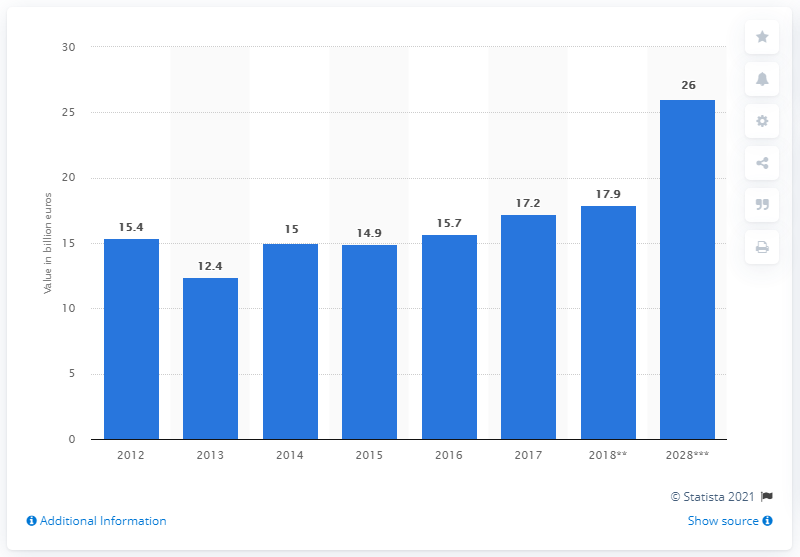Point out several critical features in this image. In 2018, the travel and tourism industry contributed 17.9% to Ireland's Gross Domestic Product (GDP). 